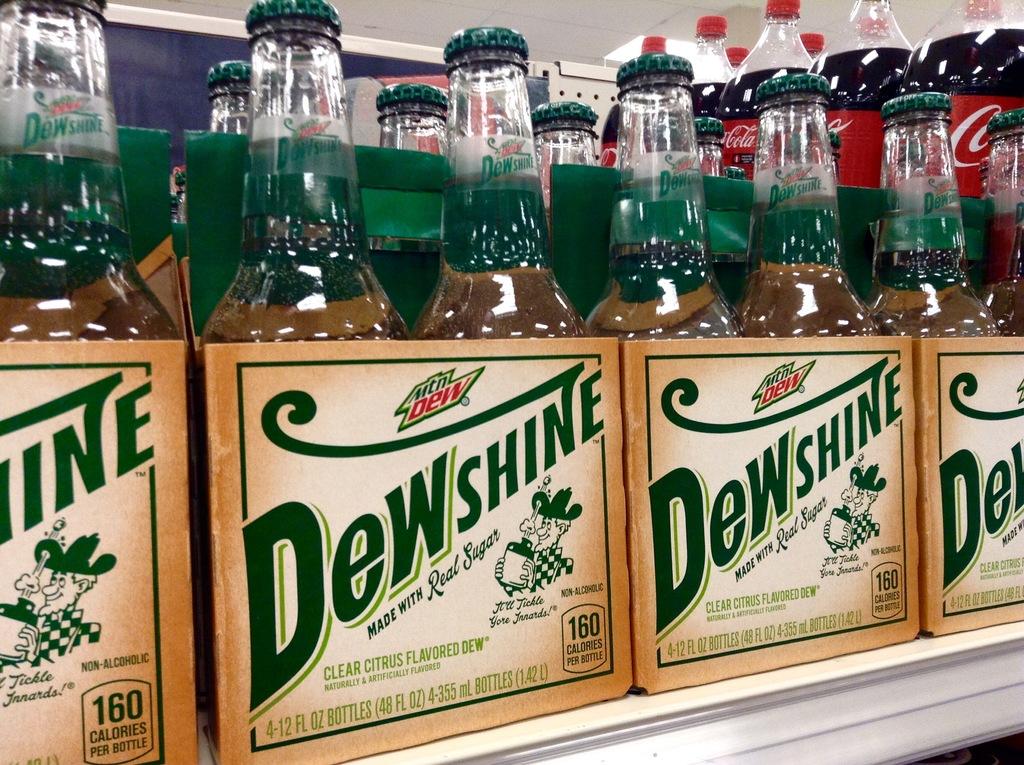Which brand drink is that?
Offer a very short reply. Dewshine. Is this drink made using cane sugar?
Make the answer very short. Yes. 